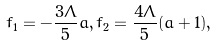Convert formula to latex. <formula><loc_0><loc_0><loc_500><loc_500>f _ { 1 } = - \frac { 3 \Lambda } { 5 } a , f _ { 2 } = \frac { 4 \Lambda } { 5 } ( a + 1 ) ,</formula> 